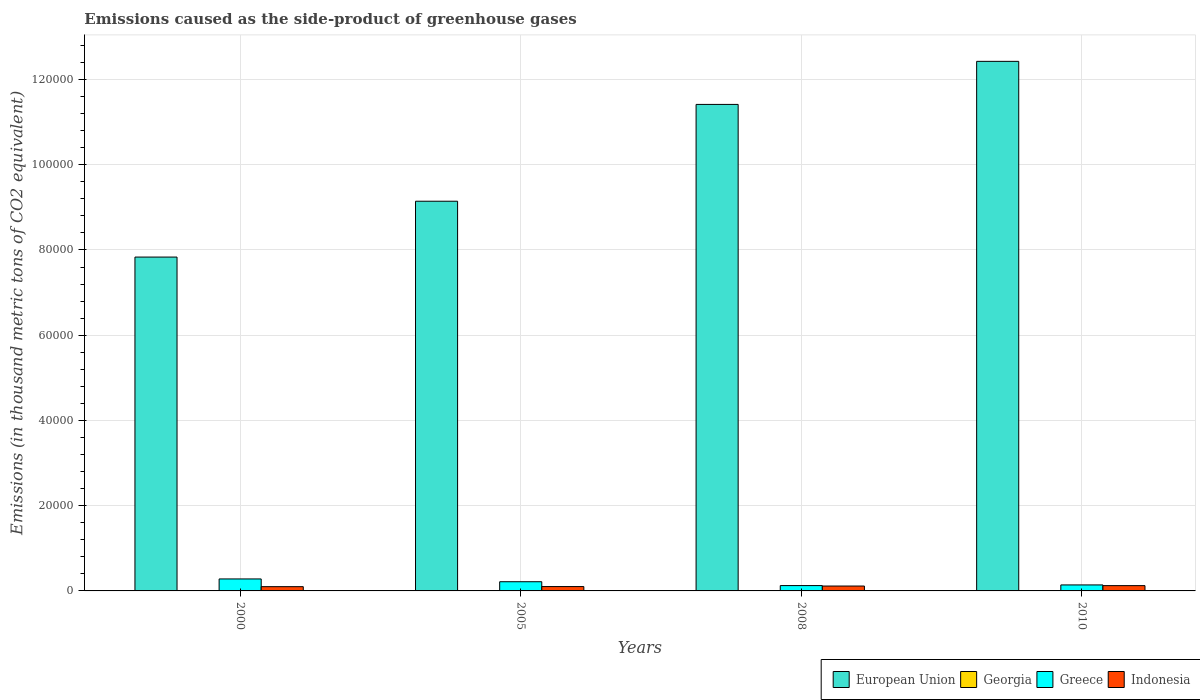How many different coloured bars are there?
Ensure brevity in your answer.  4. How many groups of bars are there?
Provide a short and direct response. 4. Are the number of bars per tick equal to the number of legend labels?
Keep it short and to the point. Yes. Are the number of bars on each tick of the X-axis equal?
Keep it short and to the point. Yes. What is the emissions caused as the side-product of greenhouse gases in European Union in 2005?
Give a very brief answer. 9.14e+04. Across all years, what is the maximum emissions caused as the side-product of greenhouse gases in Georgia?
Offer a terse response. 20. Across all years, what is the minimum emissions caused as the side-product of greenhouse gases in Greece?
Provide a succinct answer. 1250.2. What is the difference between the emissions caused as the side-product of greenhouse gases in European Union in 2000 and that in 2010?
Give a very brief answer. -4.59e+04. What is the difference between the emissions caused as the side-product of greenhouse gases in European Union in 2008 and the emissions caused as the side-product of greenhouse gases in Greece in 2010?
Provide a short and direct response. 1.13e+05. What is the average emissions caused as the side-product of greenhouse gases in Georgia per year?
Make the answer very short. 12.75. In the year 2010, what is the difference between the emissions caused as the side-product of greenhouse gases in European Union and emissions caused as the side-product of greenhouse gases in Indonesia?
Your answer should be compact. 1.23e+05. In how many years, is the emissions caused as the side-product of greenhouse gases in Georgia greater than 60000 thousand metric tons?
Provide a succinct answer. 0. What is the ratio of the emissions caused as the side-product of greenhouse gases in Indonesia in 2000 to that in 2005?
Ensure brevity in your answer.  0.98. Is the emissions caused as the side-product of greenhouse gases in Indonesia in 2008 less than that in 2010?
Provide a succinct answer. Yes. Is the difference between the emissions caused as the side-product of greenhouse gases in European Union in 2008 and 2010 greater than the difference between the emissions caused as the side-product of greenhouse gases in Indonesia in 2008 and 2010?
Keep it short and to the point. No. What is the difference between the highest and the second highest emissions caused as the side-product of greenhouse gases in Georgia?
Your response must be concise. 3.3. What is the difference between the highest and the lowest emissions caused as the side-product of greenhouse gases in Indonesia?
Ensure brevity in your answer.  243.6. In how many years, is the emissions caused as the side-product of greenhouse gases in Greece greater than the average emissions caused as the side-product of greenhouse gases in Greece taken over all years?
Ensure brevity in your answer.  2. Is the sum of the emissions caused as the side-product of greenhouse gases in Greece in 2000 and 2008 greater than the maximum emissions caused as the side-product of greenhouse gases in Georgia across all years?
Your response must be concise. Yes. What does the 3rd bar from the left in 2008 represents?
Offer a terse response. Greece. What does the 4th bar from the right in 2008 represents?
Provide a succinct answer. European Union. Is it the case that in every year, the sum of the emissions caused as the side-product of greenhouse gases in Greece and emissions caused as the side-product of greenhouse gases in Georgia is greater than the emissions caused as the side-product of greenhouse gases in Indonesia?
Give a very brief answer. Yes. How many bars are there?
Your response must be concise. 16. Are the values on the major ticks of Y-axis written in scientific E-notation?
Provide a succinct answer. No. Does the graph contain any zero values?
Offer a terse response. No. Does the graph contain grids?
Your answer should be very brief. Yes. Where does the legend appear in the graph?
Your response must be concise. Bottom right. How many legend labels are there?
Offer a very short reply. 4. How are the legend labels stacked?
Offer a terse response. Horizontal. What is the title of the graph?
Give a very brief answer. Emissions caused as the side-product of greenhouse gases. Does "South Asia" appear as one of the legend labels in the graph?
Offer a very short reply. No. What is the label or title of the Y-axis?
Make the answer very short. Emissions (in thousand metric tons of CO2 equivalent). What is the Emissions (in thousand metric tons of CO2 equivalent) of European Union in 2000?
Your response must be concise. 7.83e+04. What is the Emissions (in thousand metric tons of CO2 equivalent) in Greece in 2000?
Keep it short and to the point. 2811.5. What is the Emissions (in thousand metric tons of CO2 equivalent) of Indonesia in 2000?
Your answer should be compact. 997.4. What is the Emissions (in thousand metric tons of CO2 equivalent) in European Union in 2005?
Offer a terse response. 9.14e+04. What is the Emissions (in thousand metric tons of CO2 equivalent) of Georgia in 2005?
Offer a terse response. 11.8. What is the Emissions (in thousand metric tons of CO2 equivalent) of Greece in 2005?
Keep it short and to the point. 2157. What is the Emissions (in thousand metric tons of CO2 equivalent) of Indonesia in 2005?
Offer a terse response. 1020.5. What is the Emissions (in thousand metric tons of CO2 equivalent) in European Union in 2008?
Your response must be concise. 1.14e+05. What is the Emissions (in thousand metric tons of CO2 equivalent) of Greece in 2008?
Provide a succinct answer. 1250.2. What is the Emissions (in thousand metric tons of CO2 equivalent) in Indonesia in 2008?
Provide a succinct answer. 1146. What is the Emissions (in thousand metric tons of CO2 equivalent) in European Union in 2010?
Your answer should be very brief. 1.24e+05. What is the Emissions (in thousand metric tons of CO2 equivalent) in Greece in 2010?
Keep it short and to the point. 1407. What is the Emissions (in thousand metric tons of CO2 equivalent) of Indonesia in 2010?
Your answer should be very brief. 1241. Across all years, what is the maximum Emissions (in thousand metric tons of CO2 equivalent) of European Union?
Offer a very short reply. 1.24e+05. Across all years, what is the maximum Emissions (in thousand metric tons of CO2 equivalent) of Georgia?
Ensure brevity in your answer.  20. Across all years, what is the maximum Emissions (in thousand metric tons of CO2 equivalent) in Greece?
Provide a succinct answer. 2811.5. Across all years, what is the maximum Emissions (in thousand metric tons of CO2 equivalent) in Indonesia?
Provide a succinct answer. 1241. Across all years, what is the minimum Emissions (in thousand metric tons of CO2 equivalent) of European Union?
Provide a succinct answer. 7.83e+04. Across all years, what is the minimum Emissions (in thousand metric tons of CO2 equivalent) in Greece?
Ensure brevity in your answer.  1250.2. Across all years, what is the minimum Emissions (in thousand metric tons of CO2 equivalent) in Indonesia?
Provide a succinct answer. 997.4. What is the total Emissions (in thousand metric tons of CO2 equivalent) in European Union in the graph?
Offer a terse response. 4.08e+05. What is the total Emissions (in thousand metric tons of CO2 equivalent) of Greece in the graph?
Offer a very short reply. 7625.7. What is the total Emissions (in thousand metric tons of CO2 equivalent) in Indonesia in the graph?
Provide a succinct answer. 4404.9. What is the difference between the Emissions (in thousand metric tons of CO2 equivalent) of European Union in 2000 and that in 2005?
Your answer should be very brief. -1.31e+04. What is the difference between the Emissions (in thousand metric tons of CO2 equivalent) of Georgia in 2000 and that in 2005?
Offer a terse response. -9.3. What is the difference between the Emissions (in thousand metric tons of CO2 equivalent) of Greece in 2000 and that in 2005?
Ensure brevity in your answer.  654.5. What is the difference between the Emissions (in thousand metric tons of CO2 equivalent) of Indonesia in 2000 and that in 2005?
Your answer should be compact. -23.1. What is the difference between the Emissions (in thousand metric tons of CO2 equivalent) of European Union in 2000 and that in 2008?
Your answer should be very brief. -3.58e+04. What is the difference between the Emissions (in thousand metric tons of CO2 equivalent) in Georgia in 2000 and that in 2008?
Your answer should be compact. -14.2. What is the difference between the Emissions (in thousand metric tons of CO2 equivalent) in Greece in 2000 and that in 2008?
Offer a terse response. 1561.3. What is the difference between the Emissions (in thousand metric tons of CO2 equivalent) of Indonesia in 2000 and that in 2008?
Provide a short and direct response. -148.6. What is the difference between the Emissions (in thousand metric tons of CO2 equivalent) of European Union in 2000 and that in 2010?
Make the answer very short. -4.59e+04. What is the difference between the Emissions (in thousand metric tons of CO2 equivalent) of Georgia in 2000 and that in 2010?
Give a very brief answer. -17.5. What is the difference between the Emissions (in thousand metric tons of CO2 equivalent) of Greece in 2000 and that in 2010?
Your response must be concise. 1404.5. What is the difference between the Emissions (in thousand metric tons of CO2 equivalent) of Indonesia in 2000 and that in 2010?
Keep it short and to the point. -243.6. What is the difference between the Emissions (in thousand metric tons of CO2 equivalent) of European Union in 2005 and that in 2008?
Your answer should be very brief. -2.27e+04. What is the difference between the Emissions (in thousand metric tons of CO2 equivalent) of Greece in 2005 and that in 2008?
Keep it short and to the point. 906.8. What is the difference between the Emissions (in thousand metric tons of CO2 equivalent) in Indonesia in 2005 and that in 2008?
Offer a terse response. -125.5. What is the difference between the Emissions (in thousand metric tons of CO2 equivalent) of European Union in 2005 and that in 2010?
Keep it short and to the point. -3.28e+04. What is the difference between the Emissions (in thousand metric tons of CO2 equivalent) in Greece in 2005 and that in 2010?
Your answer should be very brief. 750. What is the difference between the Emissions (in thousand metric tons of CO2 equivalent) in Indonesia in 2005 and that in 2010?
Ensure brevity in your answer.  -220.5. What is the difference between the Emissions (in thousand metric tons of CO2 equivalent) in European Union in 2008 and that in 2010?
Make the answer very short. -1.01e+04. What is the difference between the Emissions (in thousand metric tons of CO2 equivalent) of Georgia in 2008 and that in 2010?
Ensure brevity in your answer.  -3.3. What is the difference between the Emissions (in thousand metric tons of CO2 equivalent) of Greece in 2008 and that in 2010?
Offer a terse response. -156.8. What is the difference between the Emissions (in thousand metric tons of CO2 equivalent) of Indonesia in 2008 and that in 2010?
Give a very brief answer. -95. What is the difference between the Emissions (in thousand metric tons of CO2 equivalent) in European Union in 2000 and the Emissions (in thousand metric tons of CO2 equivalent) in Georgia in 2005?
Keep it short and to the point. 7.83e+04. What is the difference between the Emissions (in thousand metric tons of CO2 equivalent) in European Union in 2000 and the Emissions (in thousand metric tons of CO2 equivalent) in Greece in 2005?
Your answer should be compact. 7.62e+04. What is the difference between the Emissions (in thousand metric tons of CO2 equivalent) in European Union in 2000 and the Emissions (in thousand metric tons of CO2 equivalent) in Indonesia in 2005?
Your response must be concise. 7.73e+04. What is the difference between the Emissions (in thousand metric tons of CO2 equivalent) of Georgia in 2000 and the Emissions (in thousand metric tons of CO2 equivalent) of Greece in 2005?
Your answer should be very brief. -2154.5. What is the difference between the Emissions (in thousand metric tons of CO2 equivalent) in Georgia in 2000 and the Emissions (in thousand metric tons of CO2 equivalent) in Indonesia in 2005?
Your answer should be compact. -1018. What is the difference between the Emissions (in thousand metric tons of CO2 equivalent) of Greece in 2000 and the Emissions (in thousand metric tons of CO2 equivalent) of Indonesia in 2005?
Your answer should be compact. 1791. What is the difference between the Emissions (in thousand metric tons of CO2 equivalent) in European Union in 2000 and the Emissions (in thousand metric tons of CO2 equivalent) in Georgia in 2008?
Your answer should be very brief. 7.83e+04. What is the difference between the Emissions (in thousand metric tons of CO2 equivalent) in European Union in 2000 and the Emissions (in thousand metric tons of CO2 equivalent) in Greece in 2008?
Provide a short and direct response. 7.71e+04. What is the difference between the Emissions (in thousand metric tons of CO2 equivalent) in European Union in 2000 and the Emissions (in thousand metric tons of CO2 equivalent) in Indonesia in 2008?
Give a very brief answer. 7.72e+04. What is the difference between the Emissions (in thousand metric tons of CO2 equivalent) in Georgia in 2000 and the Emissions (in thousand metric tons of CO2 equivalent) in Greece in 2008?
Provide a succinct answer. -1247.7. What is the difference between the Emissions (in thousand metric tons of CO2 equivalent) of Georgia in 2000 and the Emissions (in thousand metric tons of CO2 equivalent) of Indonesia in 2008?
Provide a short and direct response. -1143.5. What is the difference between the Emissions (in thousand metric tons of CO2 equivalent) in Greece in 2000 and the Emissions (in thousand metric tons of CO2 equivalent) in Indonesia in 2008?
Ensure brevity in your answer.  1665.5. What is the difference between the Emissions (in thousand metric tons of CO2 equivalent) in European Union in 2000 and the Emissions (in thousand metric tons of CO2 equivalent) in Georgia in 2010?
Make the answer very short. 7.83e+04. What is the difference between the Emissions (in thousand metric tons of CO2 equivalent) of European Union in 2000 and the Emissions (in thousand metric tons of CO2 equivalent) of Greece in 2010?
Provide a succinct answer. 7.69e+04. What is the difference between the Emissions (in thousand metric tons of CO2 equivalent) of European Union in 2000 and the Emissions (in thousand metric tons of CO2 equivalent) of Indonesia in 2010?
Make the answer very short. 7.71e+04. What is the difference between the Emissions (in thousand metric tons of CO2 equivalent) in Georgia in 2000 and the Emissions (in thousand metric tons of CO2 equivalent) in Greece in 2010?
Give a very brief answer. -1404.5. What is the difference between the Emissions (in thousand metric tons of CO2 equivalent) in Georgia in 2000 and the Emissions (in thousand metric tons of CO2 equivalent) in Indonesia in 2010?
Your answer should be very brief. -1238.5. What is the difference between the Emissions (in thousand metric tons of CO2 equivalent) of Greece in 2000 and the Emissions (in thousand metric tons of CO2 equivalent) of Indonesia in 2010?
Provide a short and direct response. 1570.5. What is the difference between the Emissions (in thousand metric tons of CO2 equivalent) of European Union in 2005 and the Emissions (in thousand metric tons of CO2 equivalent) of Georgia in 2008?
Provide a short and direct response. 9.14e+04. What is the difference between the Emissions (in thousand metric tons of CO2 equivalent) in European Union in 2005 and the Emissions (in thousand metric tons of CO2 equivalent) in Greece in 2008?
Provide a succinct answer. 9.02e+04. What is the difference between the Emissions (in thousand metric tons of CO2 equivalent) in European Union in 2005 and the Emissions (in thousand metric tons of CO2 equivalent) in Indonesia in 2008?
Your response must be concise. 9.03e+04. What is the difference between the Emissions (in thousand metric tons of CO2 equivalent) in Georgia in 2005 and the Emissions (in thousand metric tons of CO2 equivalent) in Greece in 2008?
Your answer should be compact. -1238.4. What is the difference between the Emissions (in thousand metric tons of CO2 equivalent) of Georgia in 2005 and the Emissions (in thousand metric tons of CO2 equivalent) of Indonesia in 2008?
Keep it short and to the point. -1134.2. What is the difference between the Emissions (in thousand metric tons of CO2 equivalent) in Greece in 2005 and the Emissions (in thousand metric tons of CO2 equivalent) in Indonesia in 2008?
Keep it short and to the point. 1011. What is the difference between the Emissions (in thousand metric tons of CO2 equivalent) in European Union in 2005 and the Emissions (in thousand metric tons of CO2 equivalent) in Georgia in 2010?
Give a very brief answer. 9.14e+04. What is the difference between the Emissions (in thousand metric tons of CO2 equivalent) of European Union in 2005 and the Emissions (in thousand metric tons of CO2 equivalent) of Greece in 2010?
Make the answer very short. 9.00e+04. What is the difference between the Emissions (in thousand metric tons of CO2 equivalent) in European Union in 2005 and the Emissions (in thousand metric tons of CO2 equivalent) in Indonesia in 2010?
Provide a succinct answer. 9.02e+04. What is the difference between the Emissions (in thousand metric tons of CO2 equivalent) of Georgia in 2005 and the Emissions (in thousand metric tons of CO2 equivalent) of Greece in 2010?
Your answer should be compact. -1395.2. What is the difference between the Emissions (in thousand metric tons of CO2 equivalent) of Georgia in 2005 and the Emissions (in thousand metric tons of CO2 equivalent) of Indonesia in 2010?
Your response must be concise. -1229.2. What is the difference between the Emissions (in thousand metric tons of CO2 equivalent) in Greece in 2005 and the Emissions (in thousand metric tons of CO2 equivalent) in Indonesia in 2010?
Your answer should be compact. 916. What is the difference between the Emissions (in thousand metric tons of CO2 equivalent) of European Union in 2008 and the Emissions (in thousand metric tons of CO2 equivalent) of Georgia in 2010?
Offer a terse response. 1.14e+05. What is the difference between the Emissions (in thousand metric tons of CO2 equivalent) of European Union in 2008 and the Emissions (in thousand metric tons of CO2 equivalent) of Greece in 2010?
Offer a terse response. 1.13e+05. What is the difference between the Emissions (in thousand metric tons of CO2 equivalent) in European Union in 2008 and the Emissions (in thousand metric tons of CO2 equivalent) in Indonesia in 2010?
Your answer should be very brief. 1.13e+05. What is the difference between the Emissions (in thousand metric tons of CO2 equivalent) in Georgia in 2008 and the Emissions (in thousand metric tons of CO2 equivalent) in Greece in 2010?
Your answer should be very brief. -1390.3. What is the difference between the Emissions (in thousand metric tons of CO2 equivalent) of Georgia in 2008 and the Emissions (in thousand metric tons of CO2 equivalent) of Indonesia in 2010?
Your answer should be compact. -1224.3. What is the average Emissions (in thousand metric tons of CO2 equivalent) of European Union per year?
Keep it short and to the point. 1.02e+05. What is the average Emissions (in thousand metric tons of CO2 equivalent) of Georgia per year?
Your answer should be very brief. 12.75. What is the average Emissions (in thousand metric tons of CO2 equivalent) in Greece per year?
Offer a very short reply. 1906.42. What is the average Emissions (in thousand metric tons of CO2 equivalent) in Indonesia per year?
Your response must be concise. 1101.22. In the year 2000, what is the difference between the Emissions (in thousand metric tons of CO2 equivalent) of European Union and Emissions (in thousand metric tons of CO2 equivalent) of Georgia?
Offer a very short reply. 7.83e+04. In the year 2000, what is the difference between the Emissions (in thousand metric tons of CO2 equivalent) in European Union and Emissions (in thousand metric tons of CO2 equivalent) in Greece?
Offer a very short reply. 7.55e+04. In the year 2000, what is the difference between the Emissions (in thousand metric tons of CO2 equivalent) in European Union and Emissions (in thousand metric tons of CO2 equivalent) in Indonesia?
Provide a short and direct response. 7.73e+04. In the year 2000, what is the difference between the Emissions (in thousand metric tons of CO2 equivalent) of Georgia and Emissions (in thousand metric tons of CO2 equivalent) of Greece?
Make the answer very short. -2809. In the year 2000, what is the difference between the Emissions (in thousand metric tons of CO2 equivalent) of Georgia and Emissions (in thousand metric tons of CO2 equivalent) of Indonesia?
Give a very brief answer. -994.9. In the year 2000, what is the difference between the Emissions (in thousand metric tons of CO2 equivalent) of Greece and Emissions (in thousand metric tons of CO2 equivalent) of Indonesia?
Ensure brevity in your answer.  1814.1. In the year 2005, what is the difference between the Emissions (in thousand metric tons of CO2 equivalent) in European Union and Emissions (in thousand metric tons of CO2 equivalent) in Georgia?
Provide a succinct answer. 9.14e+04. In the year 2005, what is the difference between the Emissions (in thousand metric tons of CO2 equivalent) of European Union and Emissions (in thousand metric tons of CO2 equivalent) of Greece?
Offer a very short reply. 8.93e+04. In the year 2005, what is the difference between the Emissions (in thousand metric tons of CO2 equivalent) of European Union and Emissions (in thousand metric tons of CO2 equivalent) of Indonesia?
Provide a succinct answer. 9.04e+04. In the year 2005, what is the difference between the Emissions (in thousand metric tons of CO2 equivalent) of Georgia and Emissions (in thousand metric tons of CO2 equivalent) of Greece?
Provide a short and direct response. -2145.2. In the year 2005, what is the difference between the Emissions (in thousand metric tons of CO2 equivalent) of Georgia and Emissions (in thousand metric tons of CO2 equivalent) of Indonesia?
Ensure brevity in your answer.  -1008.7. In the year 2005, what is the difference between the Emissions (in thousand metric tons of CO2 equivalent) of Greece and Emissions (in thousand metric tons of CO2 equivalent) of Indonesia?
Your answer should be compact. 1136.5. In the year 2008, what is the difference between the Emissions (in thousand metric tons of CO2 equivalent) in European Union and Emissions (in thousand metric tons of CO2 equivalent) in Georgia?
Provide a succinct answer. 1.14e+05. In the year 2008, what is the difference between the Emissions (in thousand metric tons of CO2 equivalent) of European Union and Emissions (in thousand metric tons of CO2 equivalent) of Greece?
Your answer should be very brief. 1.13e+05. In the year 2008, what is the difference between the Emissions (in thousand metric tons of CO2 equivalent) in European Union and Emissions (in thousand metric tons of CO2 equivalent) in Indonesia?
Offer a very short reply. 1.13e+05. In the year 2008, what is the difference between the Emissions (in thousand metric tons of CO2 equivalent) of Georgia and Emissions (in thousand metric tons of CO2 equivalent) of Greece?
Offer a very short reply. -1233.5. In the year 2008, what is the difference between the Emissions (in thousand metric tons of CO2 equivalent) in Georgia and Emissions (in thousand metric tons of CO2 equivalent) in Indonesia?
Provide a succinct answer. -1129.3. In the year 2008, what is the difference between the Emissions (in thousand metric tons of CO2 equivalent) of Greece and Emissions (in thousand metric tons of CO2 equivalent) of Indonesia?
Provide a short and direct response. 104.2. In the year 2010, what is the difference between the Emissions (in thousand metric tons of CO2 equivalent) in European Union and Emissions (in thousand metric tons of CO2 equivalent) in Georgia?
Your answer should be very brief. 1.24e+05. In the year 2010, what is the difference between the Emissions (in thousand metric tons of CO2 equivalent) of European Union and Emissions (in thousand metric tons of CO2 equivalent) of Greece?
Your response must be concise. 1.23e+05. In the year 2010, what is the difference between the Emissions (in thousand metric tons of CO2 equivalent) of European Union and Emissions (in thousand metric tons of CO2 equivalent) of Indonesia?
Offer a terse response. 1.23e+05. In the year 2010, what is the difference between the Emissions (in thousand metric tons of CO2 equivalent) of Georgia and Emissions (in thousand metric tons of CO2 equivalent) of Greece?
Your answer should be very brief. -1387. In the year 2010, what is the difference between the Emissions (in thousand metric tons of CO2 equivalent) in Georgia and Emissions (in thousand metric tons of CO2 equivalent) in Indonesia?
Your answer should be very brief. -1221. In the year 2010, what is the difference between the Emissions (in thousand metric tons of CO2 equivalent) in Greece and Emissions (in thousand metric tons of CO2 equivalent) in Indonesia?
Provide a short and direct response. 166. What is the ratio of the Emissions (in thousand metric tons of CO2 equivalent) of European Union in 2000 to that in 2005?
Make the answer very short. 0.86. What is the ratio of the Emissions (in thousand metric tons of CO2 equivalent) in Georgia in 2000 to that in 2005?
Make the answer very short. 0.21. What is the ratio of the Emissions (in thousand metric tons of CO2 equivalent) of Greece in 2000 to that in 2005?
Provide a short and direct response. 1.3. What is the ratio of the Emissions (in thousand metric tons of CO2 equivalent) in Indonesia in 2000 to that in 2005?
Keep it short and to the point. 0.98. What is the ratio of the Emissions (in thousand metric tons of CO2 equivalent) in European Union in 2000 to that in 2008?
Ensure brevity in your answer.  0.69. What is the ratio of the Emissions (in thousand metric tons of CO2 equivalent) of Georgia in 2000 to that in 2008?
Make the answer very short. 0.15. What is the ratio of the Emissions (in thousand metric tons of CO2 equivalent) in Greece in 2000 to that in 2008?
Your answer should be very brief. 2.25. What is the ratio of the Emissions (in thousand metric tons of CO2 equivalent) of Indonesia in 2000 to that in 2008?
Keep it short and to the point. 0.87. What is the ratio of the Emissions (in thousand metric tons of CO2 equivalent) of European Union in 2000 to that in 2010?
Ensure brevity in your answer.  0.63. What is the ratio of the Emissions (in thousand metric tons of CO2 equivalent) of Georgia in 2000 to that in 2010?
Make the answer very short. 0.12. What is the ratio of the Emissions (in thousand metric tons of CO2 equivalent) of Greece in 2000 to that in 2010?
Provide a short and direct response. 2. What is the ratio of the Emissions (in thousand metric tons of CO2 equivalent) of Indonesia in 2000 to that in 2010?
Make the answer very short. 0.8. What is the ratio of the Emissions (in thousand metric tons of CO2 equivalent) of European Union in 2005 to that in 2008?
Make the answer very short. 0.8. What is the ratio of the Emissions (in thousand metric tons of CO2 equivalent) in Georgia in 2005 to that in 2008?
Offer a terse response. 0.71. What is the ratio of the Emissions (in thousand metric tons of CO2 equivalent) of Greece in 2005 to that in 2008?
Give a very brief answer. 1.73. What is the ratio of the Emissions (in thousand metric tons of CO2 equivalent) of Indonesia in 2005 to that in 2008?
Provide a succinct answer. 0.89. What is the ratio of the Emissions (in thousand metric tons of CO2 equivalent) of European Union in 2005 to that in 2010?
Offer a terse response. 0.74. What is the ratio of the Emissions (in thousand metric tons of CO2 equivalent) of Georgia in 2005 to that in 2010?
Provide a short and direct response. 0.59. What is the ratio of the Emissions (in thousand metric tons of CO2 equivalent) in Greece in 2005 to that in 2010?
Your response must be concise. 1.53. What is the ratio of the Emissions (in thousand metric tons of CO2 equivalent) of Indonesia in 2005 to that in 2010?
Provide a short and direct response. 0.82. What is the ratio of the Emissions (in thousand metric tons of CO2 equivalent) in European Union in 2008 to that in 2010?
Give a very brief answer. 0.92. What is the ratio of the Emissions (in thousand metric tons of CO2 equivalent) of Georgia in 2008 to that in 2010?
Keep it short and to the point. 0.83. What is the ratio of the Emissions (in thousand metric tons of CO2 equivalent) in Greece in 2008 to that in 2010?
Your answer should be very brief. 0.89. What is the ratio of the Emissions (in thousand metric tons of CO2 equivalent) in Indonesia in 2008 to that in 2010?
Give a very brief answer. 0.92. What is the difference between the highest and the second highest Emissions (in thousand metric tons of CO2 equivalent) of European Union?
Provide a short and direct response. 1.01e+04. What is the difference between the highest and the second highest Emissions (in thousand metric tons of CO2 equivalent) of Greece?
Provide a succinct answer. 654.5. What is the difference between the highest and the lowest Emissions (in thousand metric tons of CO2 equivalent) in European Union?
Your response must be concise. 4.59e+04. What is the difference between the highest and the lowest Emissions (in thousand metric tons of CO2 equivalent) of Georgia?
Offer a terse response. 17.5. What is the difference between the highest and the lowest Emissions (in thousand metric tons of CO2 equivalent) of Greece?
Your answer should be compact. 1561.3. What is the difference between the highest and the lowest Emissions (in thousand metric tons of CO2 equivalent) in Indonesia?
Your response must be concise. 243.6. 